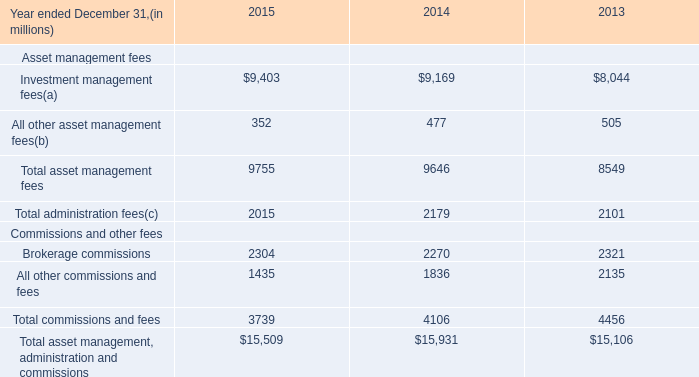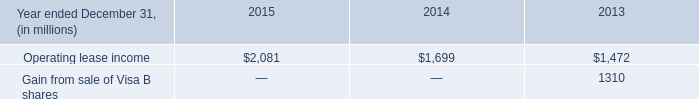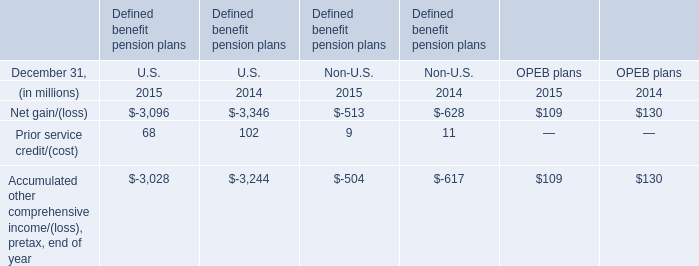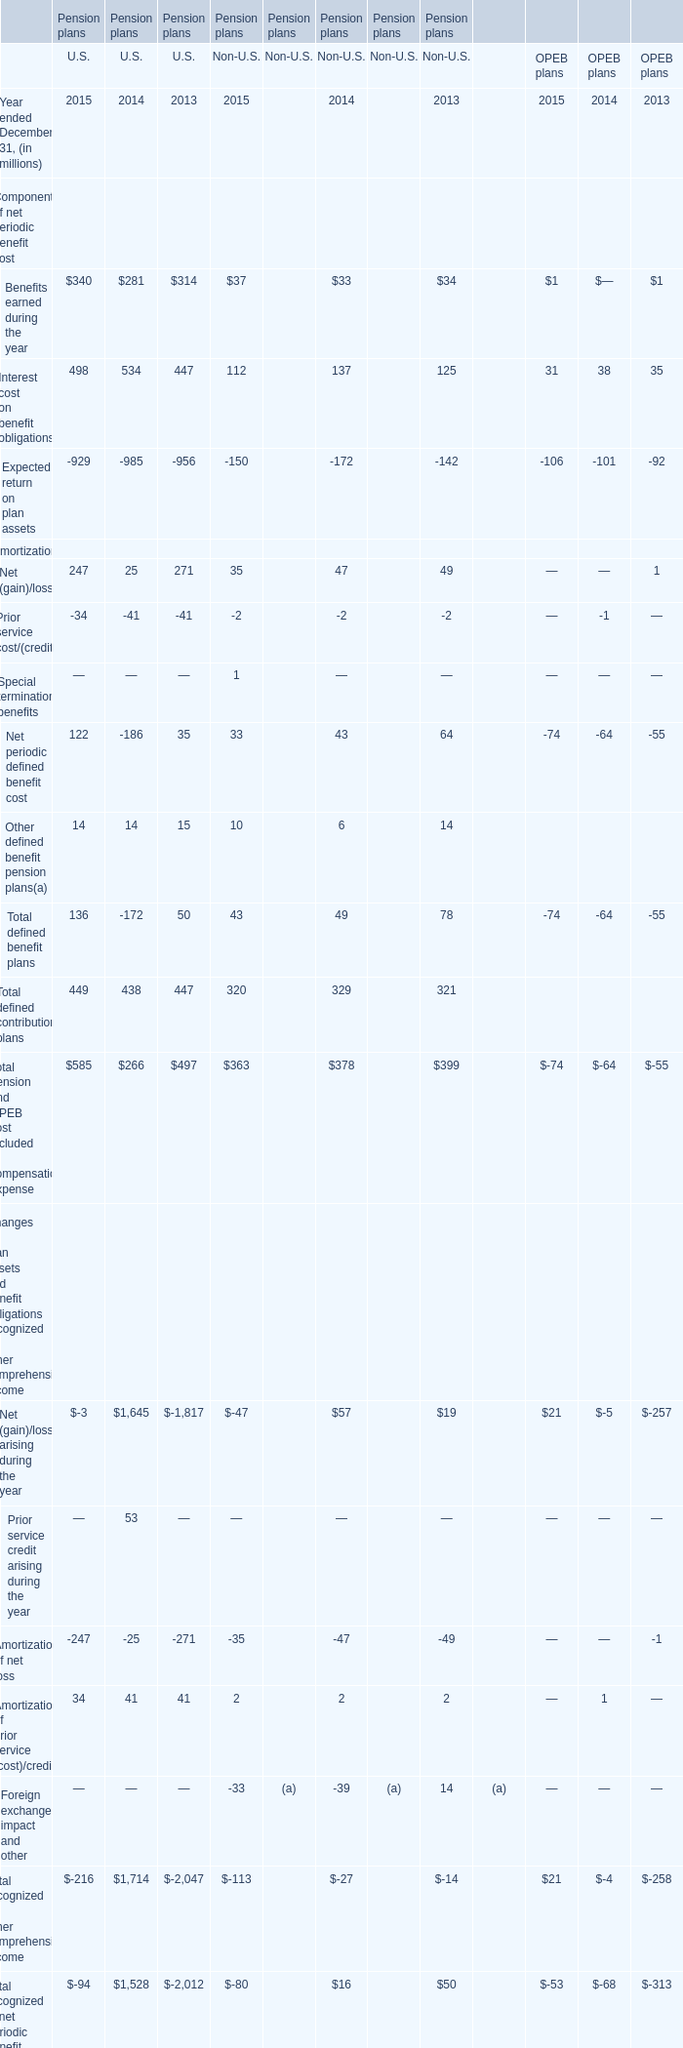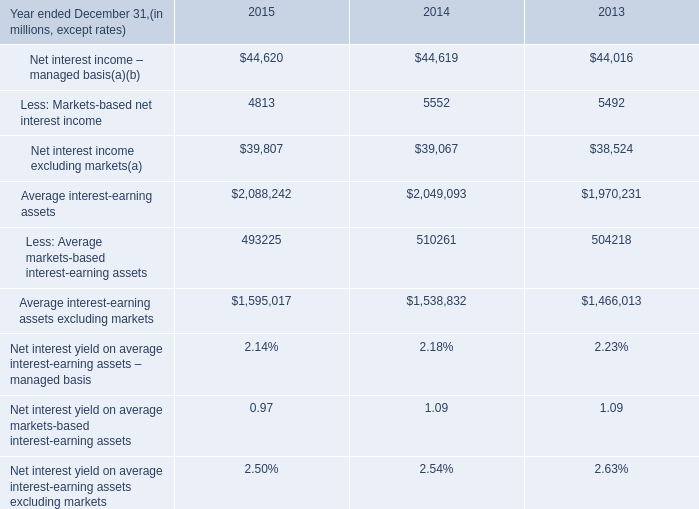What is the average amount of Operating lease income of 2014, and Net interest income – managed basis of 2014 ? 
Computations: ((1699.0 + 44619.0) / 2)
Answer: 23159.0. 